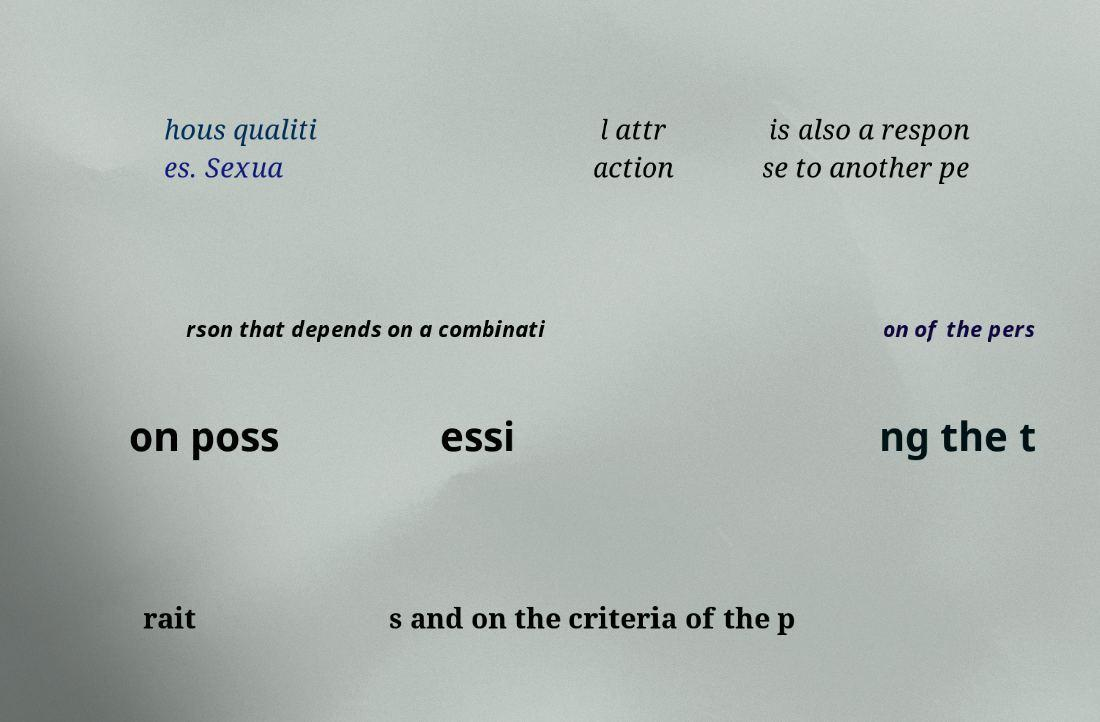What messages or text are displayed in this image? I need them in a readable, typed format. hous qualiti es. Sexua l attr action is also a respon se to another pe rson that depends on a combinati on of the pers on poss essi ng the t rait s and on the criteria of the p 